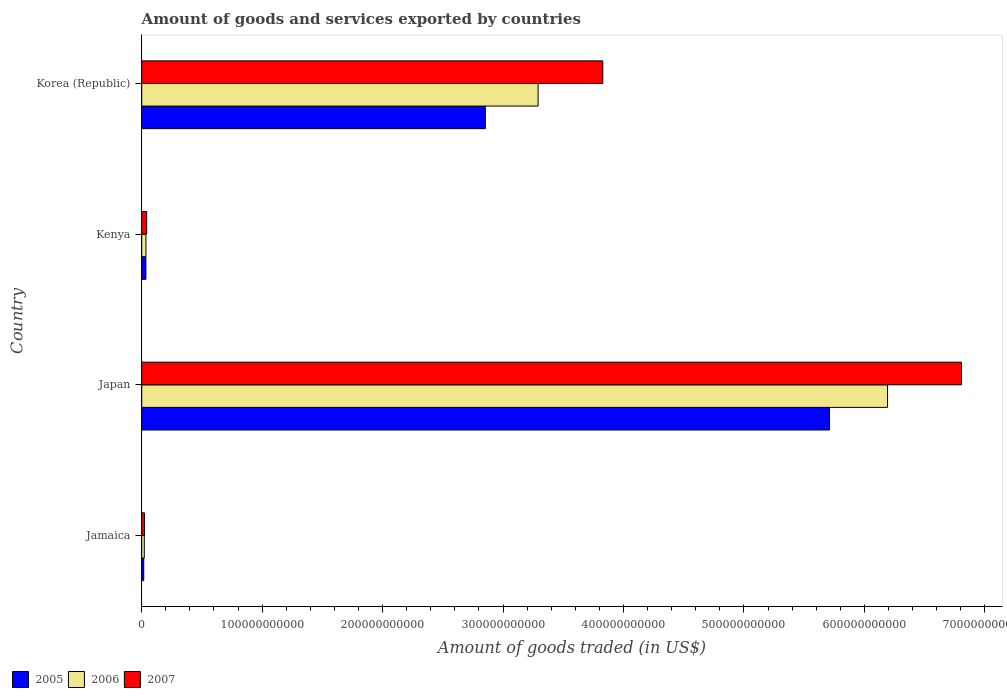Are the number of bars on each tick of the Y-axis equal?
Provide a succinct answer. Yes. How many bars are there on the 4th tick from the bottom?
Ensure brevity in your answer.  3. What is the label of the 1st group of bars from the top?
Provide a succinct answer. Korea (Republic). What is the total amount of goods and services exported in 2006 in Korea (Republic)?
Give a very brief answer. 3.29e+11. Across all countries, what is the maximum total amount of goods and services exported in 2005?
Your response must be concise. 5.71e+11. Across all countries, what is the minimum total amount of goods and services exported in 2005?
Provide a succinct answer. 1.66e+09. In which country was the total amount of goods and services exported in 2006 maximum?
Your answer should be compact. Japan. In which country was the total amount of goods and services exported in 2006 minimum?
Your answer should be compact. Jamaica. What is the total total amount of goods and services exported in 2006 in the graph?
Offer a very short reply. 9.54e+11. What is the difference between the total amount of goods and services exported in 2006 in Japan and that in Kenya?
Your answer should be very brief. 6.16e+11. What is the difference between the total amount of goods and services exported in 2007 in Japan and the total amount of goods and services exported in 2006 in Jamaica?
Offer a terse response. 6.78e+11. What is the average total amount of goods and services exported in 2005 per country?
Your response must be concise. 2.15e+11. What is the difference between the total amount of goods and services exported in 2007 and total amount of goods and services exported in 2005 in Kenya?
Provide a succinct answer. 6.64e+08. What is the ratio of the total amount of goods and services exported in 2005 in Jamaica to that in Japan?
Your answer should be very brief. 0. Is the difference between the total amount of goods and services exported in 2007 in Jamaica and Kenya greater than the difference between the total amount of goods and services exported in 2005 in Jamaica and Kenya?
Your answer should be very brief. Yes. What is the difference between the highest and the second highest total amount of goods and services exported in 2006?
Provide a succinct answer. 2.90e+11. What is the difference between the highest and the lowest total amount of goods and services exported in 2005?
Ensure brevity in your answer.  5.69e+11. In how many countries, is the total amount of goods and services exported in 2005 greater than the average total amount of goods and services exported in 2005 taken over all countries?
Ensure brevity in your answer.  2. What does the 2nd bar from the top in Korea (Republic) represents?
Provide a succinct answer. 2006. How many bars are there?
Offer a terse response. 12. Are all the bars in the graph horizontal?
Offer a very short reply. Yes. How many countries are there in the graph?
Your answer should be compact. 4. What is the difference between two consecutive major ticks on the X-axis?
Ensure brevity in your answer.  1.00e+11. Does the graph contain any zero values?
Offer a very short reply. No. Does the graph contain grids?
Offer a very short reply. No. What is the title of the graph?
Provide a short and direct response. Amount of goods and services exported by countries. Does "1984" appear as one of the legend labels in the graph?
Give a very brief answer. No. What is the label or title of the X-axis?
Provide a short and direct response. Amount of goods traded (in US$). What is the Amount of goods traded (in US$) in 2005 in Jamaica?
Offer a very short reply. 1.66e+09. What is the Amount of goods traded (in US$) in 2006 in Jamaica?
Make the answer very short. 2.13e+09. What is the Amount of goods traded (in US$) in 2007 in Jamaica?
Your answer should be compact. 2.36e+09. What is the Amount of goods traded (in US$) in 2005 in Japan?
Give a very brief answer. 5.71e+11. What is the Amount of goods traded (in US$) in 2006 in Japan?
Keep it short and to the point. 6.19e+11. What is the Amount of goods traded (in US$) of 2007 in Japan?
Give a very brief answer. 6.81e+11. What is the Amount of goods traded (in US$) in 2005 in Kenya?
Your response must be concise. 3.46e+09. What is the Amount of goods traded (in US$) of 2006 in Kenya?
Your answer should be compact. 3.51e+09. What is the Amount of goods traded (in US$) of 2007 in Kenya?
Provide a short and direct response. 4.12e+09. What is the Amount of goods traded (in US$) of 2005 in Korea (Republic)?
Your answer should be compact. 2.85e+11. What is the Amount of goods traded (in US$) of 2006 in Korea (Republic)?
Keep it short and to the point. 3.29e+11. What is the Amount of goods traded (in US$) in 2007 in Korea (Republic)?
Offer a very short reply. 3.83e+11. Across all countries, what is the maximum Amount of goods traded (in US$) of 2005?
Your answer should be compact. 5.71e+11. Across all countries, what is the maximum Amount of goods traded (in US$) of 2006?
Keep it short and to the point. 6.19e+11. Across all countries, what is the maximum Amount of goods traded (in US$) of 2007?
Your answer should be compact. 6.81e+11. Across all countries, what is the minimum Amount of goods traded (in US$) in 2005?
Your response must be concise. 1.66e+09. Across all countries, what is the minimum Amount of goods traded (in US$) of 2006?
Make the answer very short. 2.13e+09. Across all countries, what is the minimum Amount of goods traded (in US$) in 2007?
Make the answer very short. 2.36e+09. What is the total Amount of goods traded (in US$) in 2005 in the graph?
Offer a terse response. 8.61e+11. What is the total Amount of goods traded (in US$) of 2006 in the graph?
Provide a succinct answer. 9.54e+11. What is the total Amount of goods traded (in US$) of 2007 in the graph?
Your answer should be very brief. 1.07e+12. What is the difference between the Amount of goods traded (in US$) of 2005 in Jamaica and that in Japan?
Your answer should be very brief. -5.69e+11. What is the difference between the Amount of goods traded (in US$) in 2006 in Jamaica and that in Japan?
Your answer should be very brief. -6.17e+11. What is the difference between the Amount of goods traded (in US$) of 2007 in Jamaica and that in Japan?
Provide a succinct answer. -6.78e+11. What is the difference between the Amount of goods traded (in US$) of 2005 in Jamaica and that in Kenya?
Ensure brevity in your answer.  -1.80e+09. What is the difference between the Amount of goods traded (in US$) in 2006 in Jamaica and that in Kenya?
Offer a very short reply. -1.38e+09. What is the difference between the Amount of goods traded (in US$) in 2007 in Jamaica and that in Kenya?
Offer a very short reply. -1.76e+09. What is the difference between the Amount of goods traded (in US$) in 2005 in Jamaica and that in Korea (Republic)?
Provide a short and direct response. -2.84e+11. What is the difference between the Amount of goods traded (in US$) of 2006 in Jamaica and that in Korea (Republic)?
Your response must be concise. -3.27e+11. What is the difference between the Amount of goods traded (in US$) in 2007 in Jamaica and that in Korea (Republic)?
Ensure brevity in your answer.  -3.80e+11. What is the difference between the Amount of goods traded (in US$) of 2005 in Japan and that in Kenya?
Provide a succinct answer. 5.68e+11. What is the difference between the Amount of goods traded (in US$) in 2006 in Japan and that in Kenya?
Make the answer very short. 6.16e+11. What is the difference between the Amount of goods traded (in US$) in 2007 in Japan and that in Kenya?
Your answer should be very brief. 6.76e+11. What is the difference between the Amount of goods traded (in US$) of 2005 in Japan and that in Korea (Republic)?
Your response must be concise. 2.86e+11. What is the difference between the Amount of goods traded (in US$) of 2006 in Japan and that in Korea (Republic)?
Keep it short and to the point. 2.90e+11. What is the difference between the Amount of goods traded (in US$) in 2007 in Japan and that in Korea (Republic)?
Provide a succinct answer. 2.98e+11. What is the difference between the Amount of goods traded (in US$) of 2005 in Kenya and that in Korea (Republic)?
Keep it short and to the point. -2.82e+11. What is the difference between the Amount of goods traded (in US$) in 2006 in Kenya and that in Korea (Republic)?
Your answer should be very brief. -3.26e+11. What is the difference between the Amount of goods traded (in US$) in 2007 in Kenya and that in Korea (Republic)?
Offer a terse response. -3.79e+11. What is the difference between the Amount of goods traded (in US$) in 2005 in Jamaica and the Amount of goods traded (in US$) in 2006 in Japan?
Provide a short and direct response. -6.18e+11. What is the difference between the Amount of goods traded (in US$) in 2005 in Jamaica and the Amount of goods traded (in US$) in 2007 in Japan?
Your response must be concise. -6.79e+11. What is the difference between the Amount of goods traded (in US$) of 2006 in Jamaica and the Amount of goods traded (in US$) of 2007 in Japan?
Keep it short and to the point. -6.78e+11. What is the difference between the Amount of goods traded (in US$) in 2005 in Jamaica and the Amount of goods traded (in US$) in 2006 in Kenya?
Your response must be concise. -1.84e+09. What is the difference between the Amount of goods traded (in US$) in 2005 in Jamaica and the Amount of goods traded (in US$) in 2007 in Kenya?
Give a very brief answer. -2.46e+09. What is the difference between the Amount of goods traded (in US$) of 2006 in Jamaica and the Amount of goods traded (in US$) of 2007 in Kenya?
Your answer should be very brief. -1.99e+09. What is the difference between the Amount of goods traded (in US$) in 2005 in Jamaica and the Amount of goods traded (in US$) in 2006 in Korea (Republic)?
Your answer should be compact. -3.27e+11. What is the difference between the Amount of goods traded (in US$) in 2005 in Jamaica and the Amount of goods traded (in US$) in 2007 in Korea (Republic)?
Offer a terse response. -3.81e+11. What is the difference between the Amount of goods traded (in US$) of 2006 in Jamaica and the Amount of goods traded (in US$) of 2007 in Korea (Republic)?
Offer a terse response. -3.81e+11. What is the difference between the Amount of goods traded (in US$) in 2005 in Japan and the Amount of goods traded (in US$) in 2006 in Kenya?
Give a very brief answer. 5.67e+11. What is the difference between the Amount of goods traded (in US$) of 2005 in Japan and the Amount of goods traded (in US$) of 2007 in Kenya?
Keep it short and to the point. 5.67e+11. What is the difference between the Amount of goods traded (in US$) of 2006 in Japan and the Amount of goods traded (in US$) of 2007 in Kenya?
Offer a terse response. 6.15e+11. What is the difference between the Amount of goods traded (in US$) of 2005 in Japan and the Amount of goods traded (in US$) of 2006 in Korea (Republic)?
Your answer should be compact. 2.42e+11. What is the difference between the Amount of goods traded (in US$) in 2005 in Japan and the Amount of goods traded (in US$) in 2007 in Korea (Republic)?
Your answer should be compact. 1.88e+11. What is the difference between the Amount of goods traded (in US$) in 2006 in Japan and the Amount of goods traded (in US$) in 2007 in Korea (Republic)?
Provide a succinct answer. 2.36e+11. What is the difference between the Amount of goods traded (in US$) of 2005 in Kenya and the Amount of goods traded (in US$) of 2006 in Korea (Republic)?
Your answer should be compact. -3.26e+11. What is the difference between the Amount of goods traded (in US$) of 2005 in Kenya and the Amount of goods traded (in US$) of 2007 in Korea (Republic)?
Your answer should be compact. -3.79e+11. What is the difference between the Amount of goods traded (in US$) of 2006 in Kenya and the Amount of goods traded (in US$) of 2007 in Korea (Republic)?
Make the answer very short. -3.79e+11. What is the average Amount of goods traded (in US$) in 2005 per country?
Your response must be concise. 2.15e+11. What is the average Amount of goods traded (in US$) in 2006 per country?
Make the answer very short. 2.38e+11. What is the average Amount of goods traded (in US$) of 2007 per country?
Make the answer very short. 2.67e+11. What is the difference between the Amount of goods traded (in US$) in 2005 and Amount of goods traded (in US$) in 2006 in Jamaica?
Your answer should be very brief. -4.69e+08. What is the difference between the Amount of goods traded (in US$) in 2005 and Amount of goods traded (in US$) in 2007 in Jamaica?
Your answer should be very brief. -6.98e+08. What is the difference between the Amount of goods traded (in US$) in 2006 and Amount of goods traded (in US$) in 2007 in Jamaica?
Your response must be concise. -2.29e+08. What is the difference between the Amount of goods traded (in US$) in 2005 and Amount of goods traded (in US$) in 2006 in Japan?
Give a very brief answer. -4.82e+1. What is the difference between the Amount of goods traded (in US$) in 2005 and Amount of goods traded (in US$) in 2007 in Japan?
Offer a very short reply. -1.10e+11. What is the difference between the Amount of goods traded (in US$) of 2006 and Amount of goods traded (in US$) of 2007 in Japan?
Offer a terse response. -6.14e+1. What is the difference between the Amount of goods traded (in US$) in 2005 and Amount of goods traded (in US$) in 2006 in Kenya?
Make the answer very short. -4.95e+07. What is the difference between the Amount of goods traded (in US$) of 2005 and Amount of goods traded (in US$) of 2007 in Kenya?
Make the answer very short. -6.64e+08. What is the difference between the Amount of goods traded (in US$) of 2006 and Amount of goods traded (in US$) of 2007 in Kenya?
Give a very brief answer. -6.14e+08. What is the difference between the Amount of goods traded (in US$) in 2005 and Amount of goods traded (in US$) in 2006 in Korea (Republic)?
Provide a succinct answer. -4.38e+1. What is the difference between the Amount of goods traded (in US$) of 2005 and Amount of goods traded (in US$) of 2007 in Korea (Republic)?
Your answer should be very brief. -9.75e+1. What is the difference between the Amount of goods traded (in US$) in 2006 and Amount of goods traded (in US$) in 2007 in Korea (Republic)?
Ensure brevity in your answer.  -5.37e+1. What is the ratio of the Amount of goods traded (in US$) in 2005 in Jamaica to that in Japan?
Make the answer very short. 0. What is the ratio of the Amount of goods traded (in US$) in 2006 in Jamaica to that in Japan?
Your answer should be compact. 0. What is the ratio of the Amount of goods traded (in US$) in 2007 in Jamaica to that in Japan?
Your response must be concise. 0. What is the ratio of the Amount of goods traded (in US$) in 2005 in Jamaica to that in Kenya?
Ensure brevity in your answer.  0.48. What is the ratio of the Amount of goods traded (in US$) in 2006 in Jamaica to that in Kenya?
Your response must be concise. 0.61. What is the ratio of the Amount of goods traded (in US$) of 2007 in Jamaica to that in Kenya?
Your response must be concise. 0.57. What is the ratio of the Amount of goods traded (in US$) of 2005 in Jamaica to that in Korea (Republic)?
Your answer should be compact. 0.01. What is the ratio of the Amount of goods traded (in US$) of 2006 in Jamaica to that in Korea (Republic)?
Provide a succinct answer. 0.01. What is the ratio of the Amount of goods traded (in US$) in 2007 in Jamaica to that in Korea (Republic)?
Ensure brevity in your answer.  0.01. What is the ratio of the Amount of goods traded (in US$) in 2005 in Japan to that in Kenya?
Make the answer very short. 165.05. What is the ratio of the Amount of goods traded (in US$) of 2006 in Japan to that in Kenya?
Give a very brief answer. 176.47. What is the ratio of the Amount of goods traded (in US$) of 2007 in Japan to that in Kenya?
Your response must be concise. 165.07. What is the ratio of the Amount of goods traded (in US$) in 2005 in Japan to that in Korea (Republic)?
Make the answer very short. 2. What is the ratio of the Amount of goods traded (in US$) in 2006 in Japan to that in Korea (Republic)?
Offer a terse response. 1.88. What is the ratio of the Amount of goods traded (in US$) in 2007 in Japan to that in Korea (Republic)?
Give a very brief answer. 1.78. What is the ratio of the Amount of goods traded (in US$) in 2005 in Kenya to that in Korea (Republic)?
Ensure brevity in your answer.  0.01. What is the ratio of the Amount of goods traded (in US$) in 2006 in Kenya to that in Korea (Republic)?
Offer a very short reply. 0.01. What is the ratio of the Amount of goods traded (in US$) in 2007 in Kenya to that in Korea (Republic)?
Offer a terse response. 0.01. What is the difference between the highest and the second highest Amount of goods traded (in US$) of 2005?
Your response must be concise. 2.86e+11. What is the difference between the highest and the second highest Amount of goods traded (in US$) in 2006?
Offer a terse response. 2.90e+11. What is the difference between the highest and the second highest Amount of goods traded (in US$) of 2007?
Offer a terse response. 2.98e+11. What is the difference between the highest and the lowest Amount of goods traded (in US$) of 2005?
Make the answer very short. 5.69e+11. What is the difference between the highest and the lowest Amount of goods traded (in US$) of 2006?
Provide a succinct answer. 6.17e+11. What is the difference between the highest and the lowest Amount of goods traded (in US$) of 2007?
Give a very brief answer. 6.78e+11. 